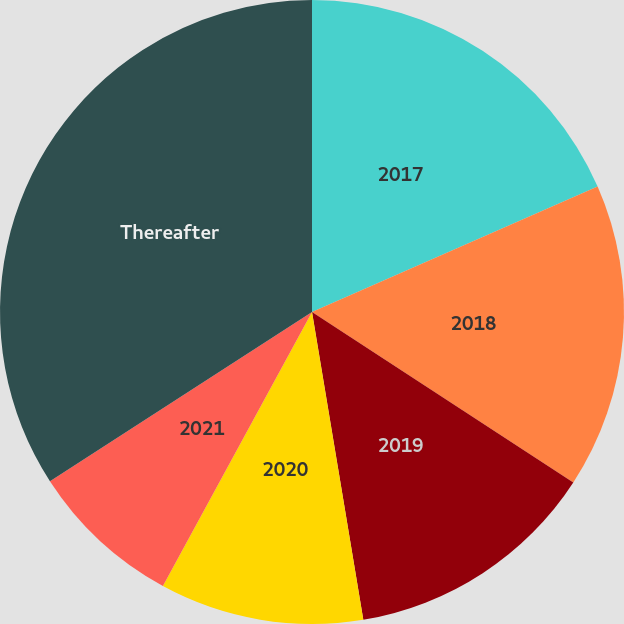Convert chart to OTSL. <chart><loc_0><loc_0><loc_500><loc_500><pie_chart><fcel>2017<fcel>2018<fcel>2019<fcel>2020<fcel>2021<fcel>Thereafter<nl><fcel>18.41%<fcel>15.79%<fcel>13.17%<fcel>10.56%<fcel>7.94%<fcel>34.13%<nl></chart> 